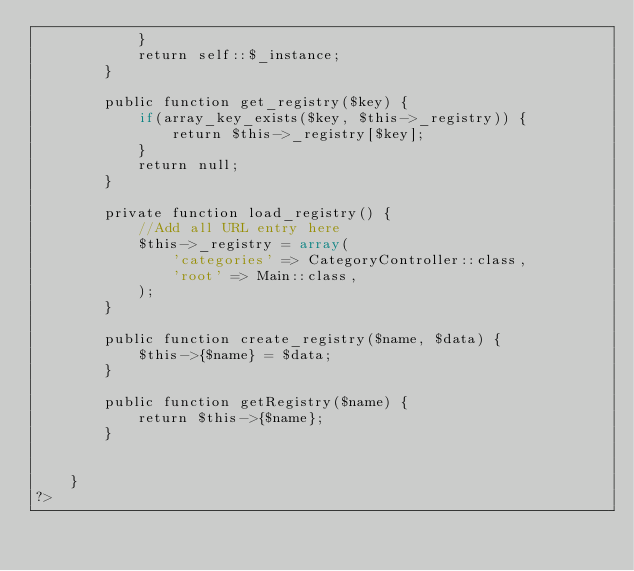<code> <loc_0><loc_0><loc_500><loc_500><_PHP_>			}
			return self::$_instance;
		}

		public function get_registry($key) {
			if(array_key_exists($key, $this->_registry)) {
				return $this->_registry[$key];
			}
			return null;
		}

		private function load_registry() {
			//Add all URL entry here
			$this->_registry = array(
				'categories' => CategoryController::class,
				'root' => Main::class,
			);
		}

		public function create_registry($name, $data) {
			$this->{$name} = $data;
		}

		public function getRegistry($name) {
			return $this->{$name};
		}


	}
?>
</code> 